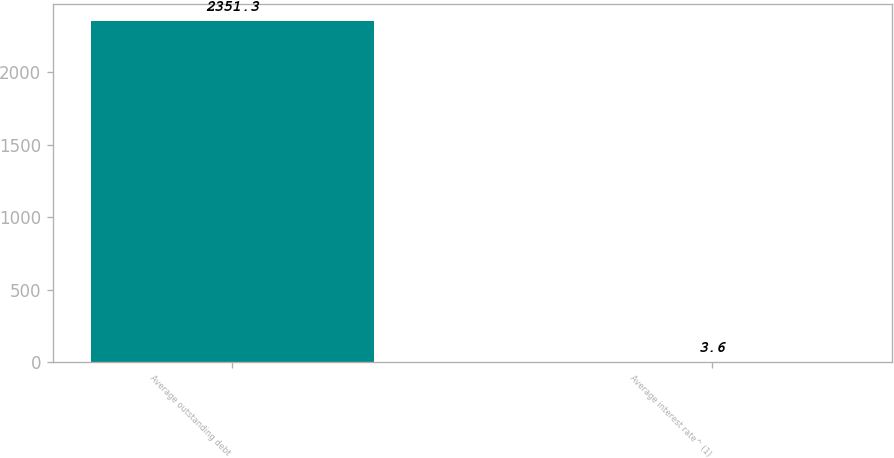<chart> <loc_0><loc_0><loc_500><loc_500><bar_chart><fcel>Average outstanding debt<fcel>Average interest rate^ (1)<nl><fcel>2351.3<fcel>3.6<nl></chart> 